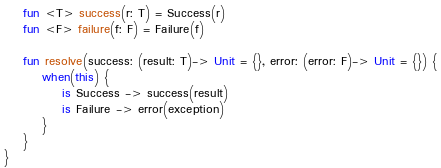Convert code to text. <code><loc_0><loc_0><loc_500><loc_500><_Kotlin_>
    fun <T> success(r: T) = Success(r)
    fun <F> failure(f: F) = Failure(f)

    fun resolve(success: (result: T)-> Unit = {}, error: (error: F)-> Unit = {}) {
        when(this) {
            is Success -> success(result)
            is Failure -> error(exception)
        }
    }
}
</code> 